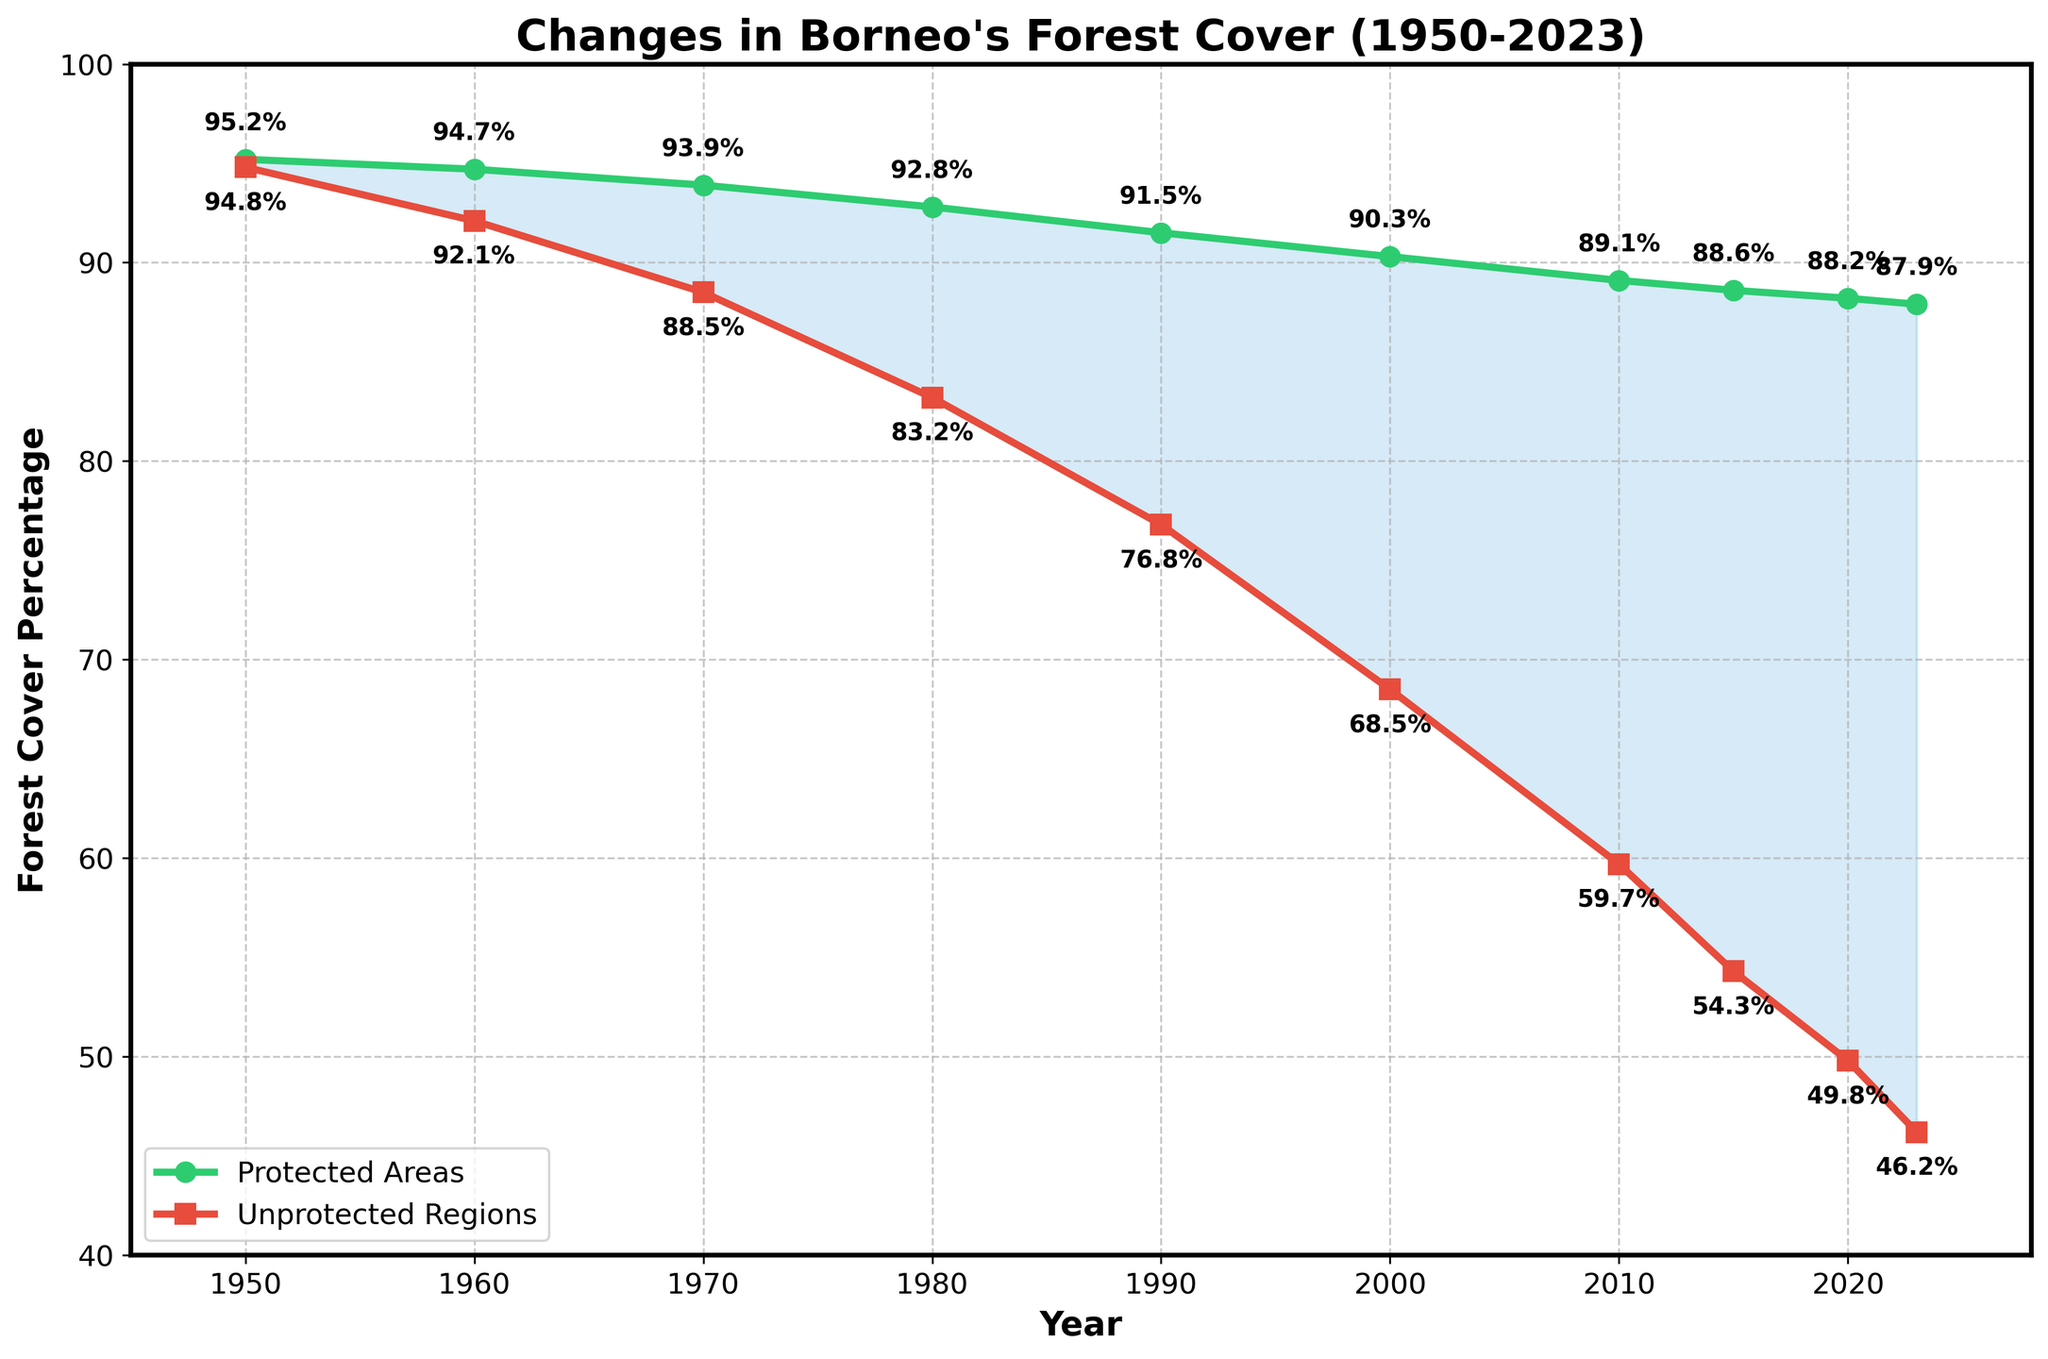What is the forest cover percentage in protected areas in 1980? Locate the year 1980 on the x-axis, then find the corresponding value on the green line representing protected areas. The value is 92.8%.
Answer: 92.8% In 2000, how much more forest cover did protected areas have compared to unprotected regions? Find the values for both protected (90.3%) and unprotected (68.5%) areas in 2000, then subtract the unprotected from the protected, i.e., 90.3% - 68.5% = 21.8%.
Answer: 21.8% What is the average forest cover percentage for protected areas from 1950 to 2023? Sum the forest cover percentages for protected areas across all years: 95.2 + 94.7 + 93.9 + 92.8 + 91.5 + 90.3 + 89.1 + 88.6 + 88.2 + 87.9 = 912.2. Then, divide by the number of years (10), i.e., 912.2 / 10 = 91.22%.
Answer: 91.22% Which year saw the largest difference in forest cover percentage between protected and unprotected areas? Calculate the differences between protected and unprotected areas for each year: 1950: 0.4, 1960: 2.6, 1970: 5.4, 1980: 9.6, 1990: 14.7, 2000: 21.8, 2010: 29.4, 2015: 34.3, 2020: 38.4, 2023: 41.7. The largest difference is in 2023.
Answer: 2023 How has the forest cover percentage in unprotected regions changed from 1950 to 2023? Compare the forest cover percentage in unprotected regions between 1950 (94.8%) and 2023 (46.2%). The percentage has decreased by 94.8% - 46.2% = 48.6%.
Answer: Decreased by 48.6% What trend can be observed in the forest cover percentage in protected areas from 1950 to 2023? Observe the green line, which shows a general downward trend, indicating a consistent decrease in the forest cover percentage in protected areas over the years.
Answer: Decreasing trend In which year did the unprotected regions first have less than 50% forest cover? Follow the red line representing unprotected regions and identify the first year where the value drops below 50%. This happens in 2020.
Answer: 2020 Between which consecutive years did protected areas experience the smallest decrease in forest cover percentage? Calculate the differences between consecutive years' forest cover percentages for protected areas: 1950 to 1960: 0.5, 1960 to 1970: 0.8, 1970 to 1980: 1.1, 1980 to 1990: 1.3, 1990 to 2000: 1.2, 2000 to 2010: 1.2, 2010 to 2015: 0.5, 2015 to 2020: 0.4, 2020 to 2023: 0.3. The smallest decrease is between 2020 and 2023.
Answer: 2020 to 2023 What visual attribute distinguishes the protected areas' line from the unprotected regions' line? The protected areas' line is green with circular markers, while the unprotected regions' line is red with square markers.
Answer: Green line with circular markers vs. red line with square markers Which region (protected or unprotected) shows a more rapid decline in forest cover percentage over time? Observe the slopes of both lines; the red line for unprotected regions declines more steeply compared to the green line for protected areas, indicating a more rapid decline in forest cover.
Answer: Unprotected regions 